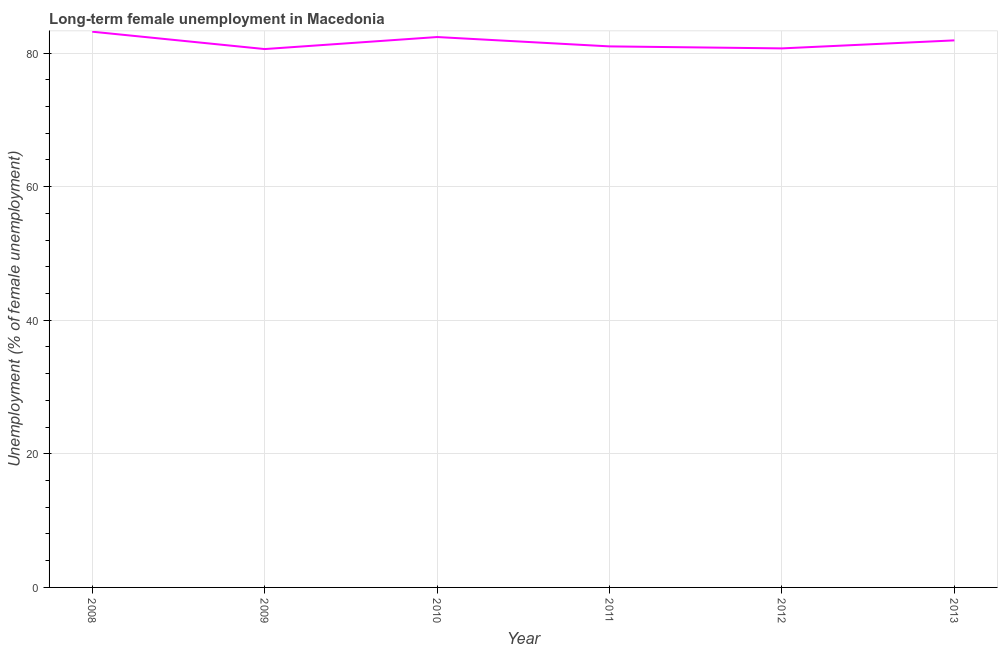What is the long-term female unemployment in 2012?
Give a very brief answer. 80.7. Across all years, what is the maximum long-term female unemployment?
Make the answer very short. 83.2. Across all years, what is the minimum long-term female unemployment?
Ensure brevity in your answer.  80.6. In which year was the long-term female unemployment maximum?
Provide a succinct answer. 2008. What is the sum of the long-term female unemployment?
Provide a short and direct response. 489.8. What is the difference between the long-term female unemployment in 2009 and 2010?
Offer a terse response. -1.8. What is the average long-term female unemployment per year?
Your answer should be very brief. 81.63. What is the median long-term female unemployment?
Your answer should be compact. 81.45. In how many years, is the long-term female unemployment greater than 28 %?
Your answer should be compact. 6. What is the ratio of the long-term female unemployment in 2008 to that in 2012?
Give a very brief answer. 1.03. Is the long-term female unemployment in 2010 less than that in 2012?
Your response must be concise. No. What is the difference between the highest and the second highest long-term female unemployment?
Offer a terse response. 0.8. What is the difference between the highest and the lowest long-term female unemployment?
Your response must be concise. 2.6. Does the graph contain any zero values?
Offer a terse response. No. What is the title of the graph?
Offer a terse response. Long-term female unemployment in Macedonia. What is the label or title of the Y-axis?
Offer a terse response. Unemployment (% of female unemployment). What is the Unemployment (% of female unemployment) of 2008?
Provide a short and direct response. 83.2. What is the Unemployment (% of female unemployment) of 2009?
Your response must be concise. 80.6. What is the Unemployment (% of female unemployment) of 2010?
Give a very brief answer. 82.4. What is the Unemployment (% of female unemployment) in 2012?
Your answer should be very brief. 80.7. What is the Unemployment (% of female unemployment) in 2013?
Your answer should be compact. 81.9. What is the difference between the Unemployment (% of female unemployment) in 2008 and 2009?
Offer a very short reply. 2.6. What is the difference between the Unemployment (% of female unemployment) in 2008 and 2010?
Offer a terse response. 0.8. What is the difference between the Unemployment (% of female unemployment) in 2009 and 2012?
Provide a short and direct response. -0.1. What is the difference between the Unemployment (% of female unemployment) in 2009 and 2013?
Your answer should be compact. -1.3. What is the difference between the Unemployment (% of female unemployment) in 2010 and 2011?
Make the answer very short. 1.4. What is the difference between the Unemployment (% of female unemployment) in 2011 and 2013?
Give a very brief answer. -0.9. What is the difference between the Unemployment (% of female unemployment) in 2012 and 2013?
Your response must be concise. -1.2. What is the ratio of the Unemployment (% of female unemployment) in 2008 to that in 2009?
Your answer should be compact. 1.03. What is the ratio of the Unemployment (% of female unemployment) in 2008 to that in 2011?
Provide a succinct answer. 1.03. What is the ratio of the Unemployment (% of female unemployment) in 2008 to that in 2012?
Provide a succinct answer. 1.03. What is the ratio of the Unemployment (% of female unemployment) in 2009 to that in 2012?
Offer a very short reply. 1. What is the ratio of the Unemployment (% of female unemployment) in 2010 to that in 2013?
Offer a terse response. 1.01. What is the ratio of the Unemployment (% of female unemployment) in 2011 to that in 2013?
Ensure brevity in your answer.  0.99. What is the ratio of the Unemployment (% of female unemployment) in 2012 to that in 2013?
Ensure brevity in your answer.  0.98. 